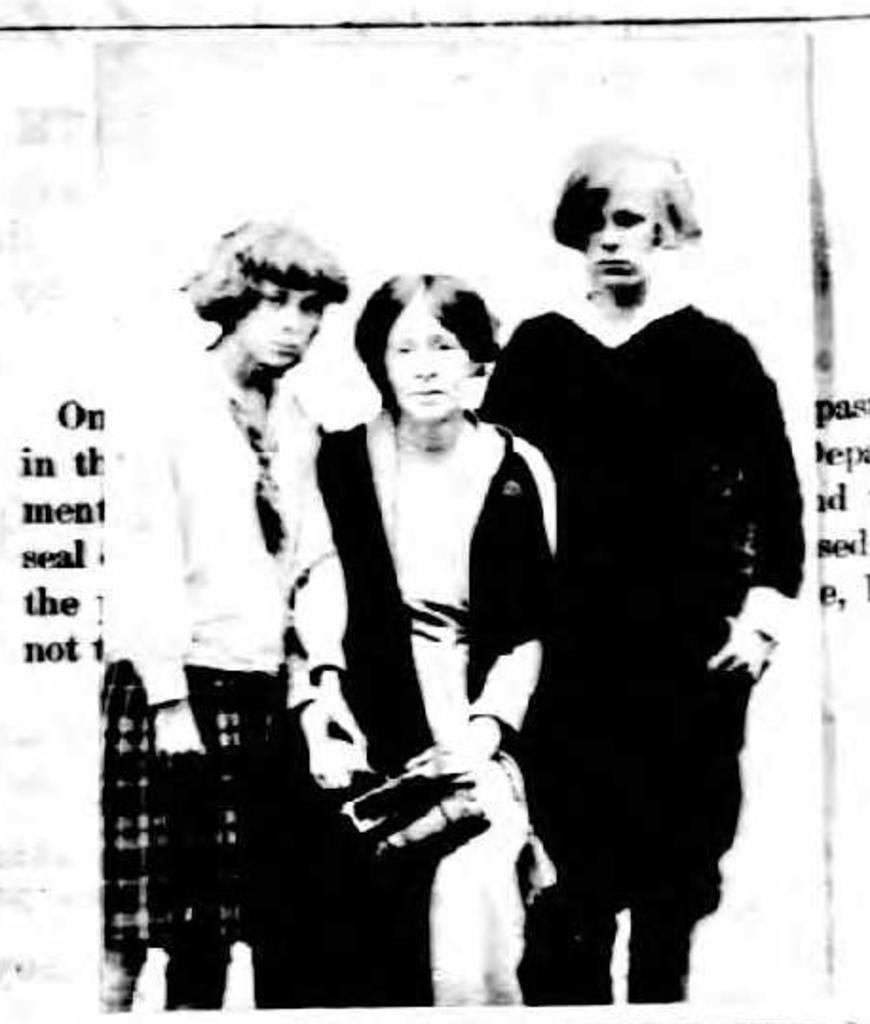What is the color scheme of the image? The picture is black and white. How many people are in the image? There are three people standing in the middle of the image. Is there any text present in the image? Yes, there is text on either side of the image. What direction are the people facing in the image? The provided facts do not specify the direction the people are facing, so we cannot definitively answer this question. Is there a hydrant visible in the image? No, there is no hydrant present in the image. 